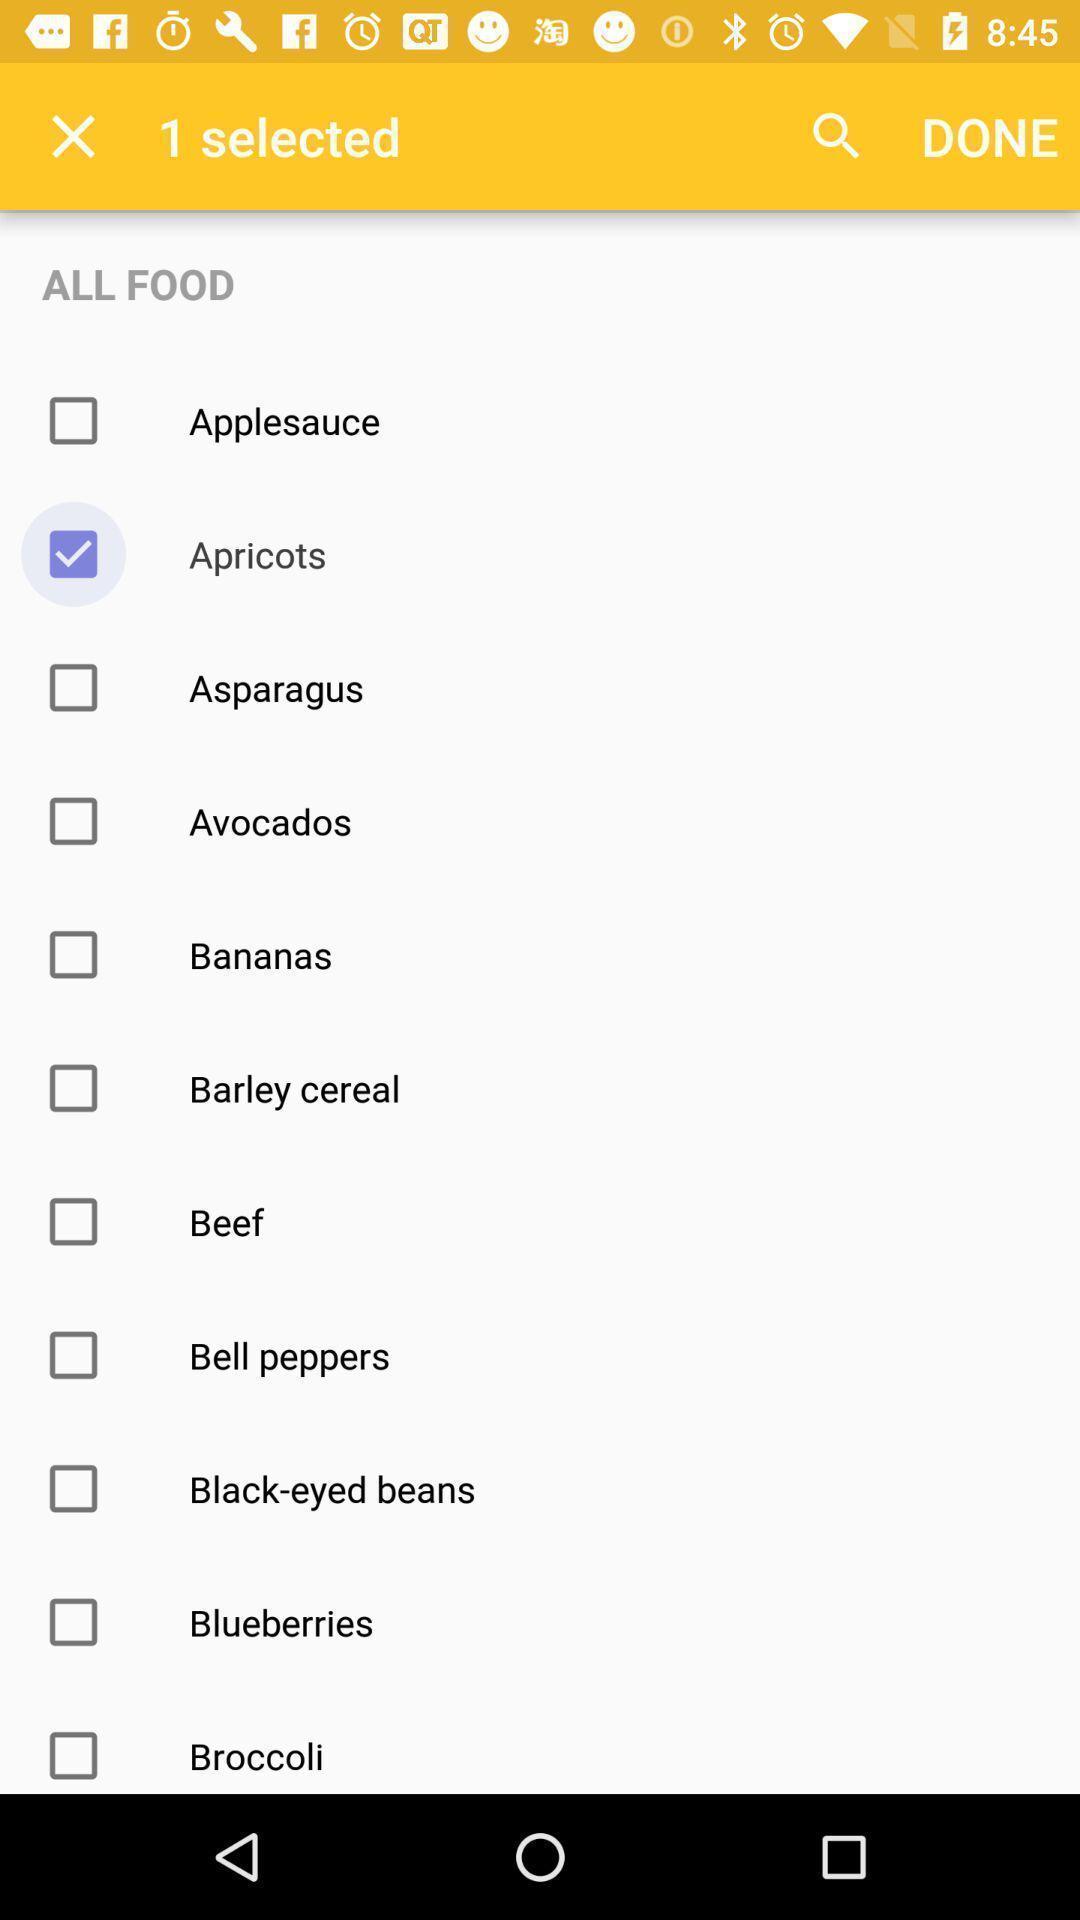Describe this image in words. Screen shows list of foods in baby tracker application. 